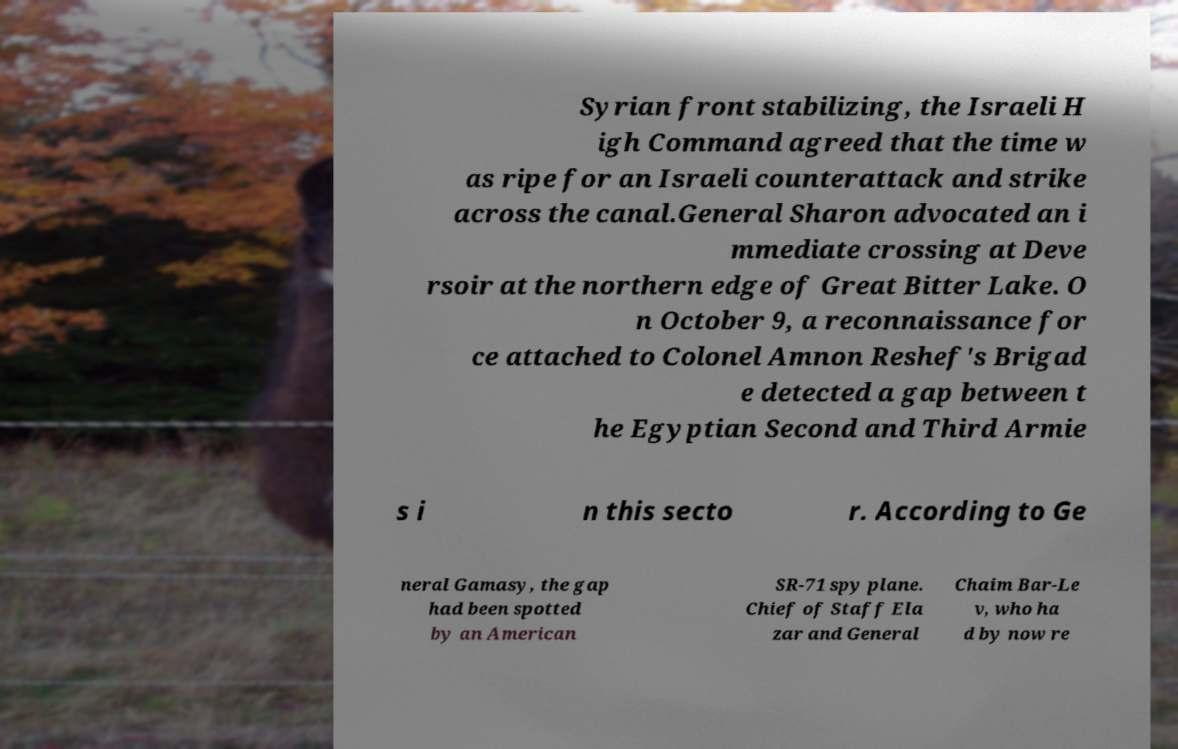For documentation purposes, I need the text within this image transcribed. Could you provide that? Syrian front stabilizing, the Israeli H igh Command agreed that the time w as ripe for an Israeli counterattack and strike across the canal.General Sharon advocated an i mmediate crossing at Deve rsoir at the northern edge of Great Bitter Lake. O n October 9, a reconnaissance for ce attached to Colonel Amnon Reshef's Brigad e detected a gap between t he Egyptian Second and Third Armie s i n this secto r. According to Ge neral Gamasy, the gap had been spotted by an American SR-71 spy plane. Chief of Staff Ela zar and General Chaim Bar-Le v, who ha d by now re 